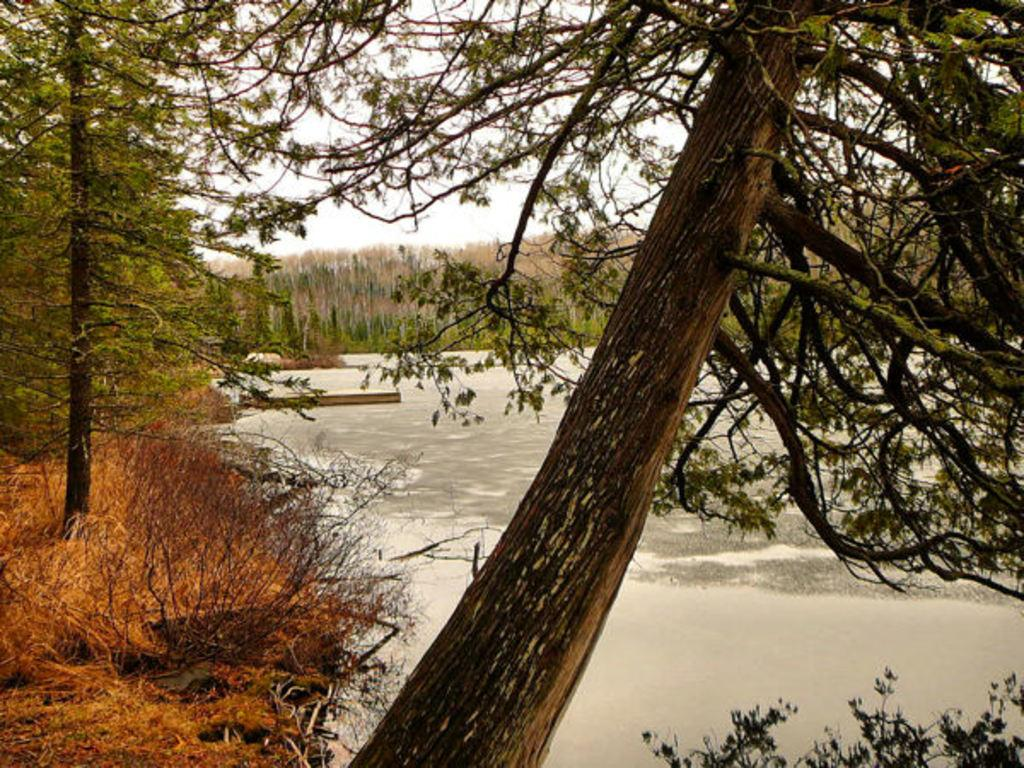What is located in the left corner of the image? There is a tree in the left corner of the image. What is near the tree in the image? There is water beside the tree. What can be seen in the background of the image? There are other trees in the background of the image. How many buns are floating on the water in the image? There are no buns present in the image; it features a tree and water. What type of boats can be seen navigating the water in the image? There are no boats present in the image; it features a tree and water. 